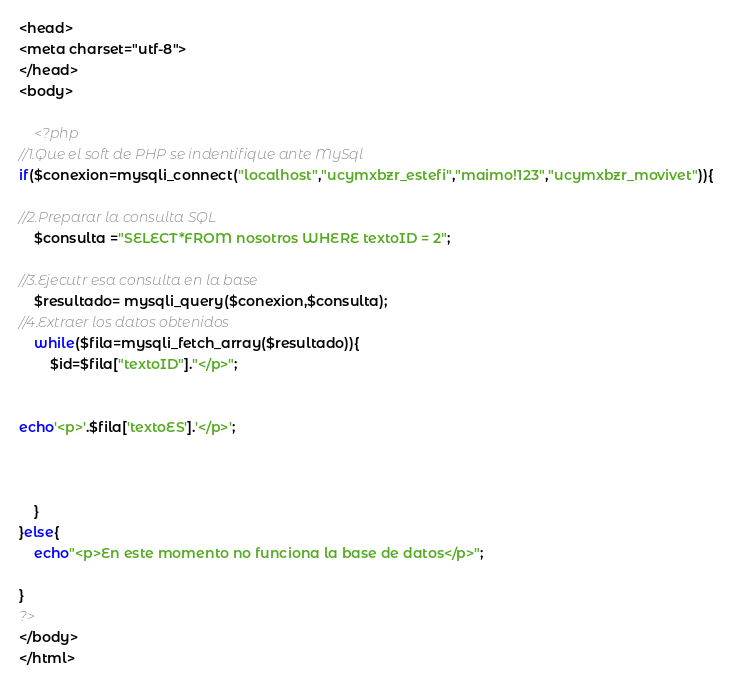Convert code to text. <code><loc_0><loc_0><loc_500><loc_500><_PHP_><head>
<meta charset="utf-8">
</head>
<body>
		
	<?php
//1.Que el soft de PHP se indentifique ante MySql
if($conexion=mysqli_connect("localhost","ucymxbzr_estefi","maimo!123","ucymxbzr_movivet")){

//2.Preparar la consulta SQL
	$consulta ="SELECT*FROM nosotros WHERE textoID = 2";

//3.Ejecutr esa consulta en la base
	$resultado= mysqli_query($conexion,$consulta);
//4.Extraer los datos obtenidos
	while($fila=mysqli_fetch_array($resultado)){
		$id=$fila["textoID"]."</p>";
		
	
echo'<p>'.$fila['textoES'].'</p>';

	

	}
}else{
	echo"<p>En este momento no funciona la base de datos</p>";

}
?>
</body>
</html></code> 